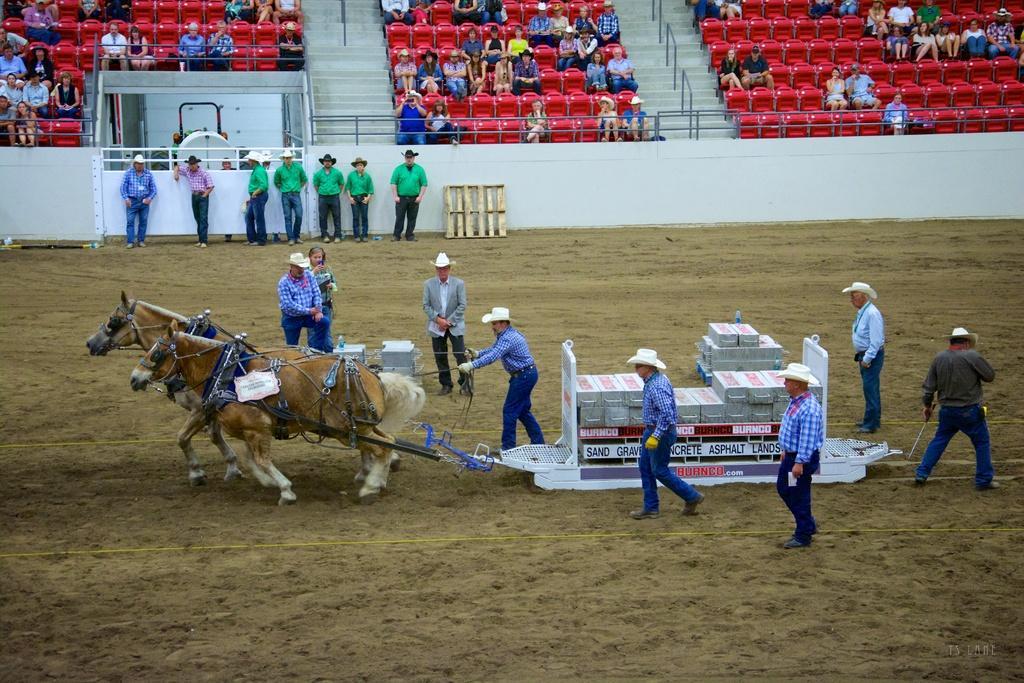Please provide a concise description of this image. In the image we can see there is a horse cart and there are boxes kept in the cart. There are people standing and they are wearing hats. There are other people standing on the ground and they are wearing hats. Behind there are spectators sitting on the chairs. 